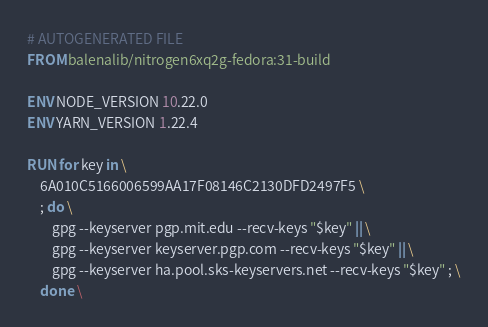<code> <loc_0><loc_0><loc_500><loc_500><_Dockerfile_># AUTOGENERATED FILE
FROM balenalib/nitrogen6xq2g-fedora:31-build

ENV NODE_VERSION 10.22.0
ENV YARN_VERSION 1.22.4

RUN for key in \
	6A010C5166006599AA17F08146C2130DFD2497F5 \
	; do \
		gpg --keyserver pgp.mit.edu --recv-keys "$key" || \
		gpg --keyserver keyserver.pgp.com --recv-keys "$key" || \
		gpg --keyserver ha.pool.sks-keyservers.net --recv-keys "$key" ; \
	done \</code> 